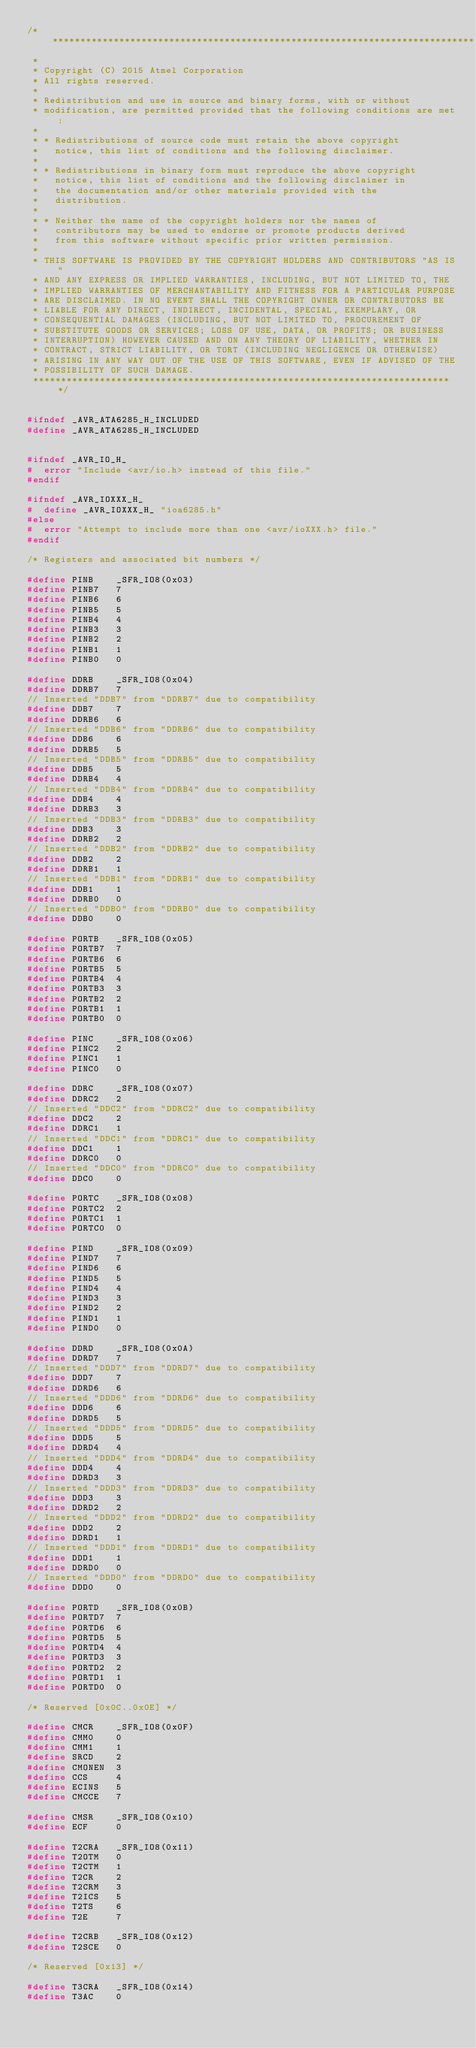<code> <loc_0><loc_0><loc_500><loc_500><_C_>/*****************************************************************************
 *
 * Copyright (C) 2015 Atmel Corporation
 * All rights reserved.
 *
 * Redistribution and use in source and binary forms, with or without
 * modification, are permitted provided that the following conditions are met:
 *
 * * Redistributions of source code must retain the above copyright
 *   notice, this list of conditions and the following disclaimer.
 *
 * * Redistributions in binary form must reproduce the above copyright
 *   notice, this list of conditions and the following disclaimer in
 *   the documentation and/or other materials provided with the
 *   distribution.
 *
 * * Neither the name of the copyright holders nor the names of
 *   contributors may be used to endorse or promote products derived
 *   from this software without specific prior written permission.
 *
 * THIS SOFTWARE IS PROVIDED BY THE COPYRIGHT HOLDERS AND CONTRIBUTORS "AS IS"
 * AND ANY EXPRESS OR IMPLIED WARRANTIES, INCLUDING, BUT NOT LIMITED TO, THE
 * IMPLIED WARRANTIES OF MERCHANTABILITY AND FITNESS FOR A PARTICULAR PURPOSE
 * ARE DISCLAIMED. IN NO EVENT SHALL THE COPYRIGHT OWNER OR CONTRIBUTORS BE
 * LIABLE FOR ANY DIRECT, INDIRECT, INCIDENTAL, SPECIAL, EXEMPLARY, OR
 * CONSEQUENTIAL DAMAGES (INCLUDING, BUT NOT LIMITED TO, PROCUREMENT OF
 * SUBSTITUTE GOODS OR SERVICES; LOSS OF USE, DATA, OR PROFITS; OR BUSINESS
 * INTERRUPTION) HOWEVER CAUSED AND ON ANY THEORY OF LIABILITY, WHETHER IN
 * CONTRACT, STRICT LIABILITY, OR TORT (INCLUDING NEGLIGENCE OR OTHERWISE)
 * ARISING IN ANY WAY OUT OF THE USE OF THIS SOFTWARE, EVEN IF ADVISED OF THE
 * POSSIBILITY OF SUCH DAMAGE.
 ****************************************************************************/


#ifndef _AVR_ATA6285_H_INCLUDED
#define _AVR_ATA6285_H_INCLUDED


#ifndef _AVR_IO_H_
#  error "Include <avr/io.h> instead of this file."
#endif

#ifndef _AVR_IOXXX_H_
#  define _AVR_IOXXX_H_ "ioa6285.h"
#else
#  error "Attempt to include more than one <avr/ioXXX.h> file."
#endif

/* Registers and associated bit numbers */

#define PINB    _SFR_IO8(0x03)
#define PINB7   7
#define PINB6   6
#define PINB5   5
#define PINB4   4
#define PINB3   3
#define PINB2   2
#define PINB1   1
#define PINB0   0

#define DDRB    _SFR_IO8(0x04)
#define DDRB7   7
// Inserted "DDB7" from "DDRB7" due to compatibility
#define DDB7    7
#define DDRB6   6
// Inserted "DDB6" from "DDRB6" due to compatibility
#define DDB6    6
#define DDRB5   5
// Inserted "DDB5" from "DDRB5" due to compatibility
#define DDB5    5
#define DDRB4   4
// Inserted "DDB4" from "DDRB4" due to compatibility
#define DDB4    4
#define DDRB3   3
// Inserted "DDB3" from "DDRB3" due to compatibility
#define DDB3    3
#define DDRB2   2
// Inserted "DDB2" from "DDRB2" due to compatibility
#define DDB2    2
#define DDRB1   1
// Inserted "DDB1" from "DDRB1" due to compatibility
#define DDB1    1
#define DDRB0   0
// Inserted "DDB0" from "DDRB0" due to compatibility
#define DDB0    0

#define PORTB   _SFR_IO8(0x05)
#define PORTB7  7
#define PORTB6  6
#define PORTB5  5
#define PORTB4  4
#define PORTB3  3
#define PORTB2  2
#define PORTB1  1
#define PORTB0  0

#define PINC    _SFR_IO8(0x06)
#define PINC2   2
#define PINC1   1
#define PINC0   0

#define DDRC    _SFR_IO8(0x07)
#define DDRC2   2
// Inserted "DDC2" from "DDRC2" due to compatibility
#define DDC2    2
#define DDRC1   1
// Inserted "DDC1" from "DDRC1" due to compatibility
#define DDC1    1
#define DDRC0   0
// Inserted "DDC0" from "DDRC0" due to compatibility
#define DDC0    0

#define PORTC   _SFR_IO8(0x08)
#define PORTC2  2
#define PORTC1  1
#define PORTC0  0

#define PIND    _SFR_IO8(0x09)
#define PIND7   7
#define PIND6   6
#define PIND5   5
#define PIND4   4
#define PIND3   3
#define PIND2   2
#define PIND1   1
#define PIND0   0

#define DDRD    _SFR_IO8(0x0A)
#define DDRD7   7
// Inserted "DDD7" from "DDRD7" due to compatibility
#define DDD7    7
#define DDRD6   6
// Inserted "DDD6" from "DDRD6" due to compatibility
#define DDD6    6
#define DDRD5   5
// Inserted "DDD5" from "DDRD5" due to compatibility
#define DDD5    5
#define DDRD4   4
// Inserted "DDD4" from "DDRD4" due to compatibility
#define DDD4    4
#define DDRD3   3
// Inserted "DDD3" from "DDRD3" due to compatibility
#define DDD3    3
#define DDRD2   2
// Inserted "DDD2" from "DDRD2" due to compatibility
#define DDD2    2
#define DDRD1   1
// Inserted "DDD1" from "DDRD1" due to compatibility
#define DDD1    1
#define DDRD0   0
// Inserted "DDD0" from "DDRD0" due to compatibility
#define DDD0    0

#define PORTD   _SFR_IO8(0x0B)
#define PORTD7  7
#define PORTD6  6
#define PORTD5  5
#define PORTD4  4
#define PORTD3  3
#define PORTD2  2
#define PORTD1  1
#define PORTD0  0

/* Reserved [0x0C..0x0E] */

#define CMCR    _SFR_IO8(0x0F)
#define CMM0    0
#define CMM1    1
#define SRCD    2
#define CMONEN  3
#define CCS     4
#define ECINS   5
#define CMCCE   7

#define CMSR    _SFR_IO8(0x10)
#define ECF     0

#define T2CRA   _SFR_IO8(0x11)
#define T2OTM   0
#define T2CTM   1
#define T2CR    2
#define T2CRM   3
#define T2ICS   5
#define T2TS    6
#define T2E     7

#define T2CRB   _SFR_IO8(0x12)
#define T2SCE   0

/* Reserved [0x13] */

#define T3CRA   _SFR_IO8(0x14)
#define T3AC    0</code> 